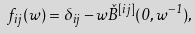<formula> <loc_0><loc_0><loc_500><loc_500>f _ { i j } ( w ) = \delta _ { i j } - w \check { B } ^ { [ i j ] } ( 0 , w ^ { - 1 } ) ,</formula> 